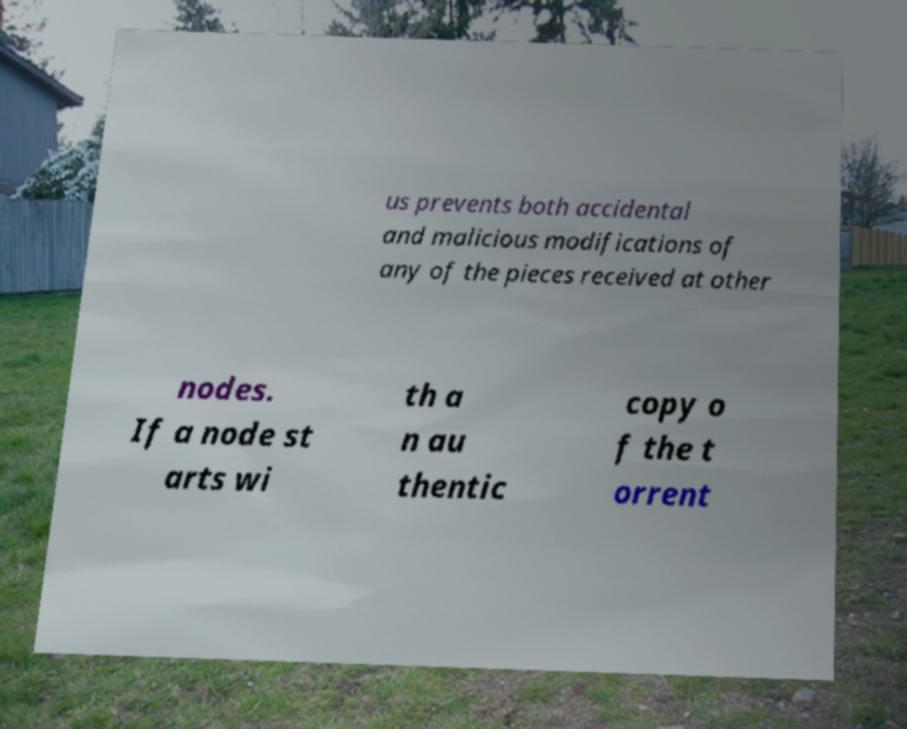I need the written content from this picture converted into text. Can you do that? us prevents both accidental and malicious modifications of any of the pieces received at other nodes. If a node st arts wi th a n au thentic copy o f the t orrent 